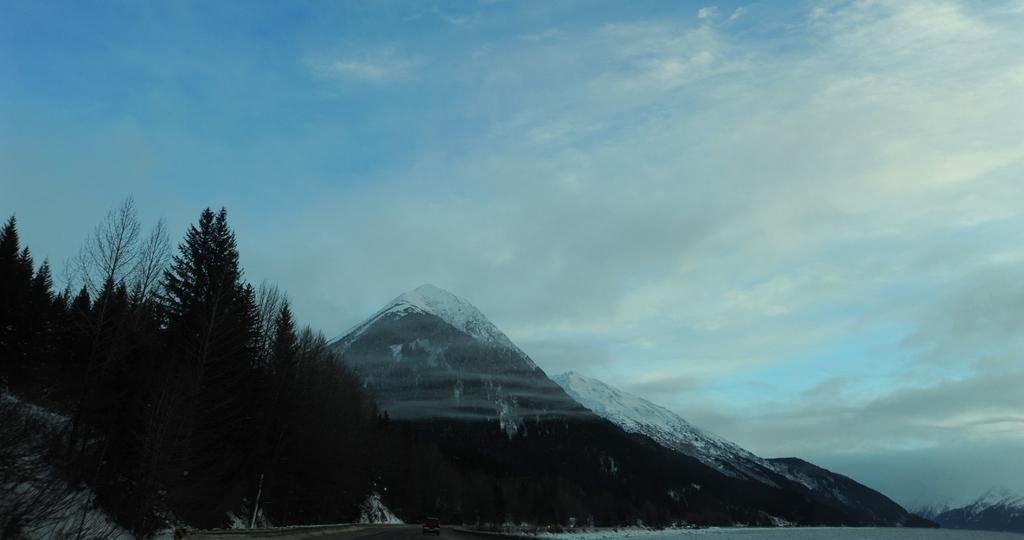What type of vegetation is on the left side of the image? There are trees on the left side of the image. What can be seen in the background of the image? There are hills in the background of the image. What is covering the hills in the image? The hills are covered with ice. What is visible at the top of the image? The sky is visible at the top of the image. What color is the sky in the image? The sky is blue in color. What type of oatmeal is being prepared on the trees in the image? There is no oatmeal present in the image; it features trees, hills, and a blue sky. What color is the powder covering the trees in the image? There is no powder covering the trees in the image; they are simply trees with no additional substances. 